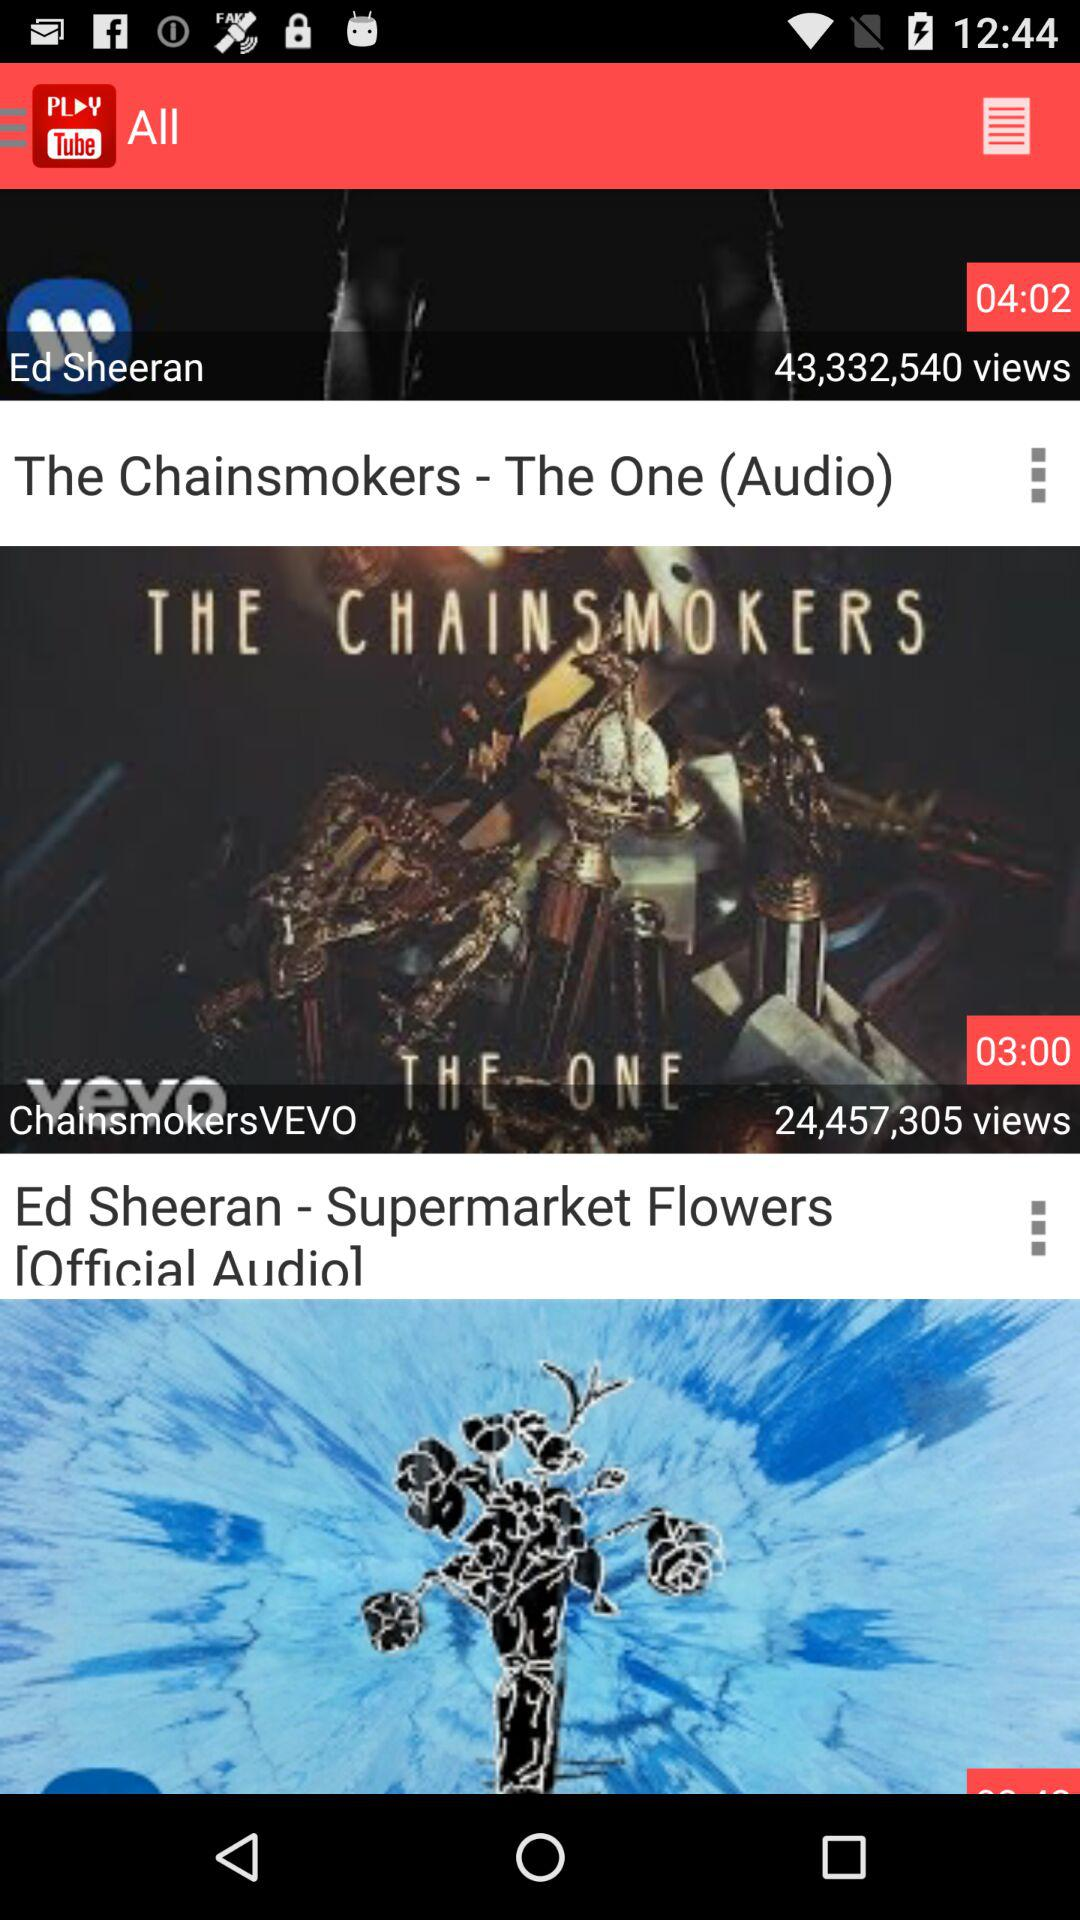Describe the visual elements present in the video thumbnails. The thumbnail for The Chainsmokers features what seems to be a robotic or mechanical structure created from musical instruments, hinting at a fusion of technology with music. For Ed Sheeran's track, we see a floral pattern with deep blue colors, which might evoke a feeling of melancholy or introspection associated with the song. 